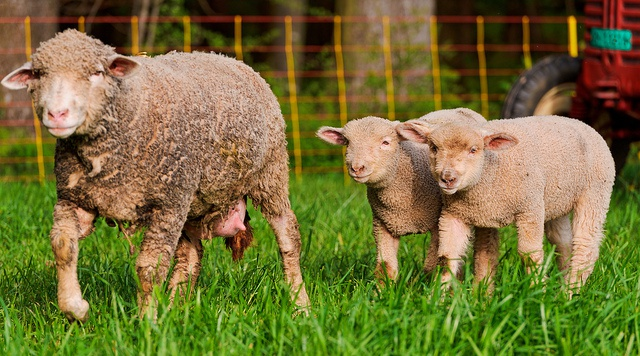Describe the objects in this image and their specific colors. I can see sheep in brown, tan, and gray tones, sheep in brown and tan tones, and sheep in brown, tan, olive, and gray tones in this image. 